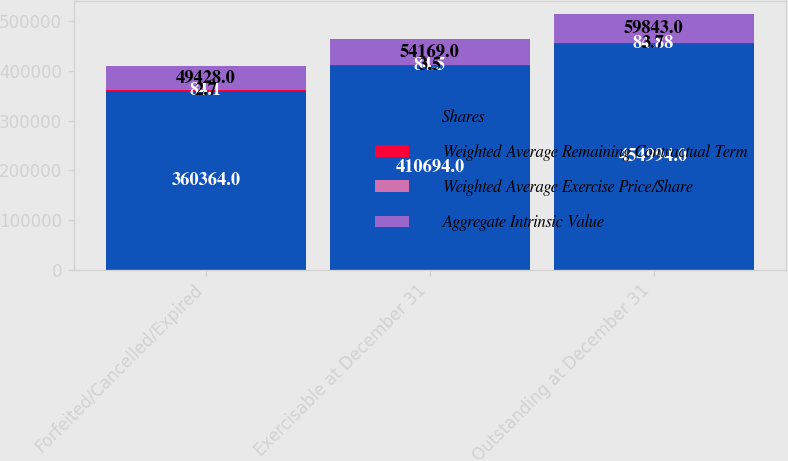Convert chart. <chart><loc_0><loc_0><loc_500><loc_500><stacked_bar_chart><ecel><fcel>Forfeited/Cancelled/Expired<fcel>Exercisable at December 31<fcel>Outstanding at December 31<nl><fcel>Shares<fcel>360364<fcel>410694<fcel>454994<nl><fcel>Weighted Average Remaining Contractual Term<fcel>84.1<fcel>84.5<fcel>84.88<nl><fcel>Weighted Average Exercise Price/Share<fcel>2.7<fcel>3.5<fcel>3.7<nl><fcel>Aggregate Intrinsic Value<fcel>49428<fcel>54169<fcel>59843<nl></chart> 